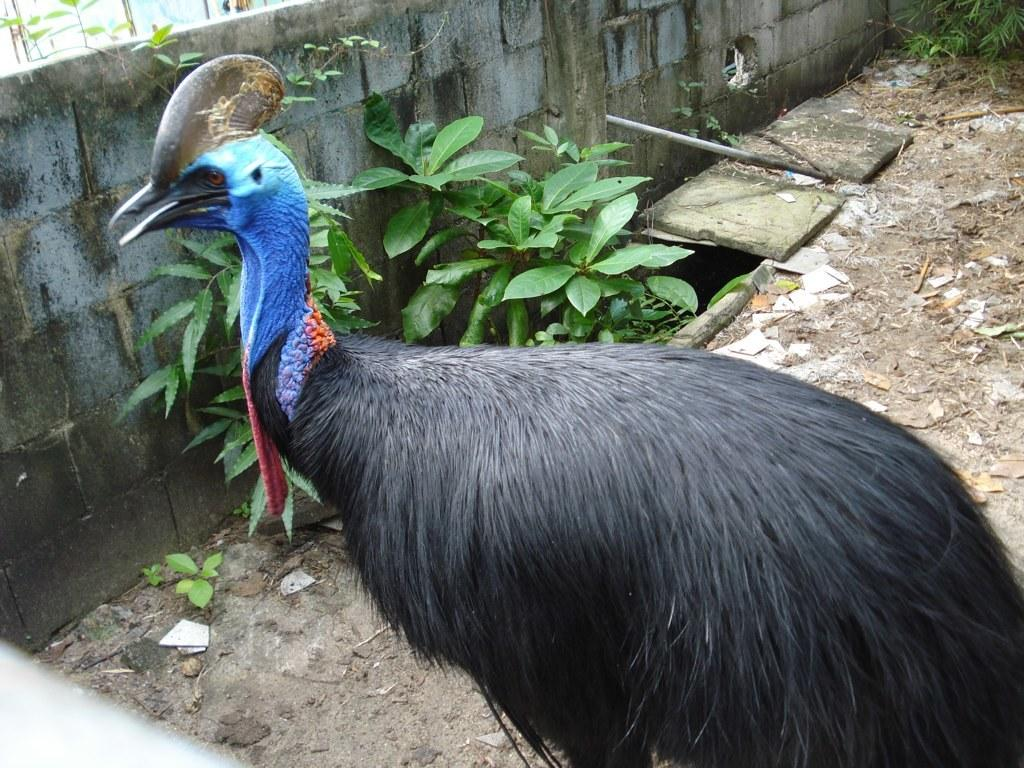What type of animal is in the picture? There is a Cassowary in the picture. Where is the Cassowary located in the image? The Cassowary is present over a place. What other elements can be seen in the picture? There are plants present in the picture. What type of zipper can be seen on the Cassowary in the image? There is no zipper present on the Cassowary in the image, as it is a living animal and not a garment or object with a zipper. 